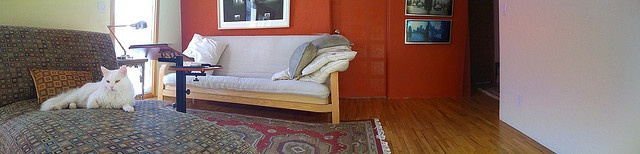Describe the objects in this image and their specific colors. I can see bed in olive, gray, black, and maroon tones, couch in olive, darkgray, tan, and lightgray tones, and cat in olive, darkgray, lightgray, and gray tones in this image. 